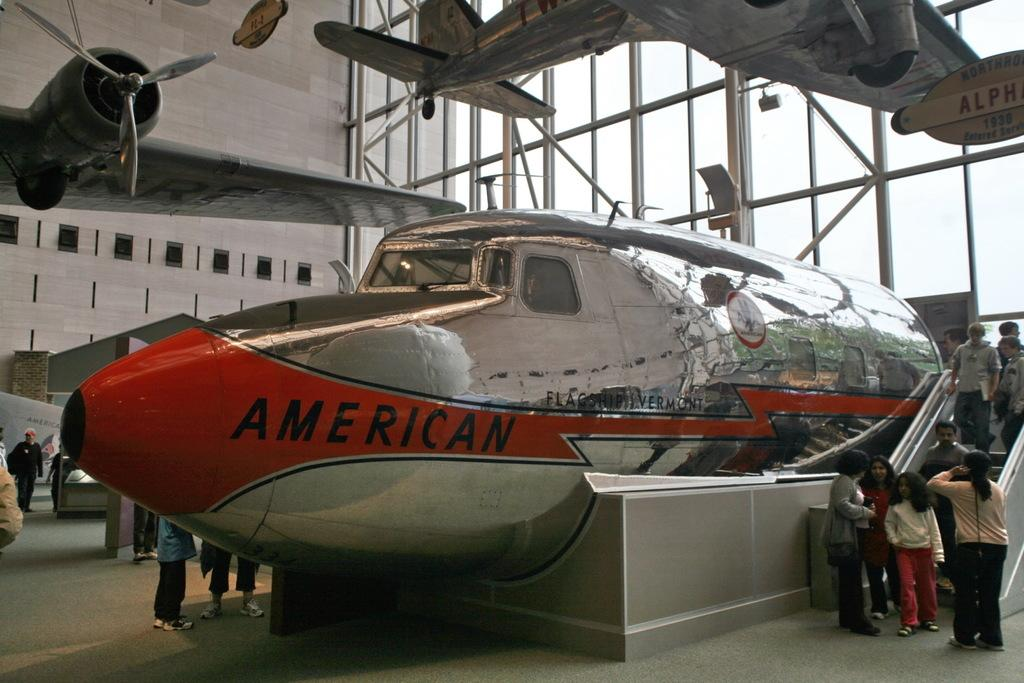<image>
Relay a brief, clear account of the picture shown. A silver plane that says American is on display in a museum. 